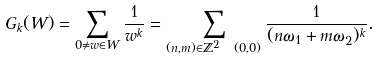<formula> <loc_0><loc_0><loc_500><loc_500>G _ { k } ( W ) = \sum _ { 0 \neq w \in W } \frac { 1 } { w ^ { k } } = \sum _ { ( n , m ) \in \mathbb { Z } ^ { 2 } \ ( 0 , 0 ) } \frac { 1 } { ( n \omega _ { 1 } + m \omega _ { 2 } ) ^ { k } } .</formula> 